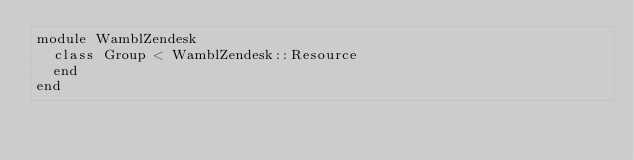Convert code to text. <code><loc_0><loc_0><loc_500><loc_500><_Ruby_>module WamblZendesk
  class Group < WamblZendesk::Resource
  end
end
</code> 